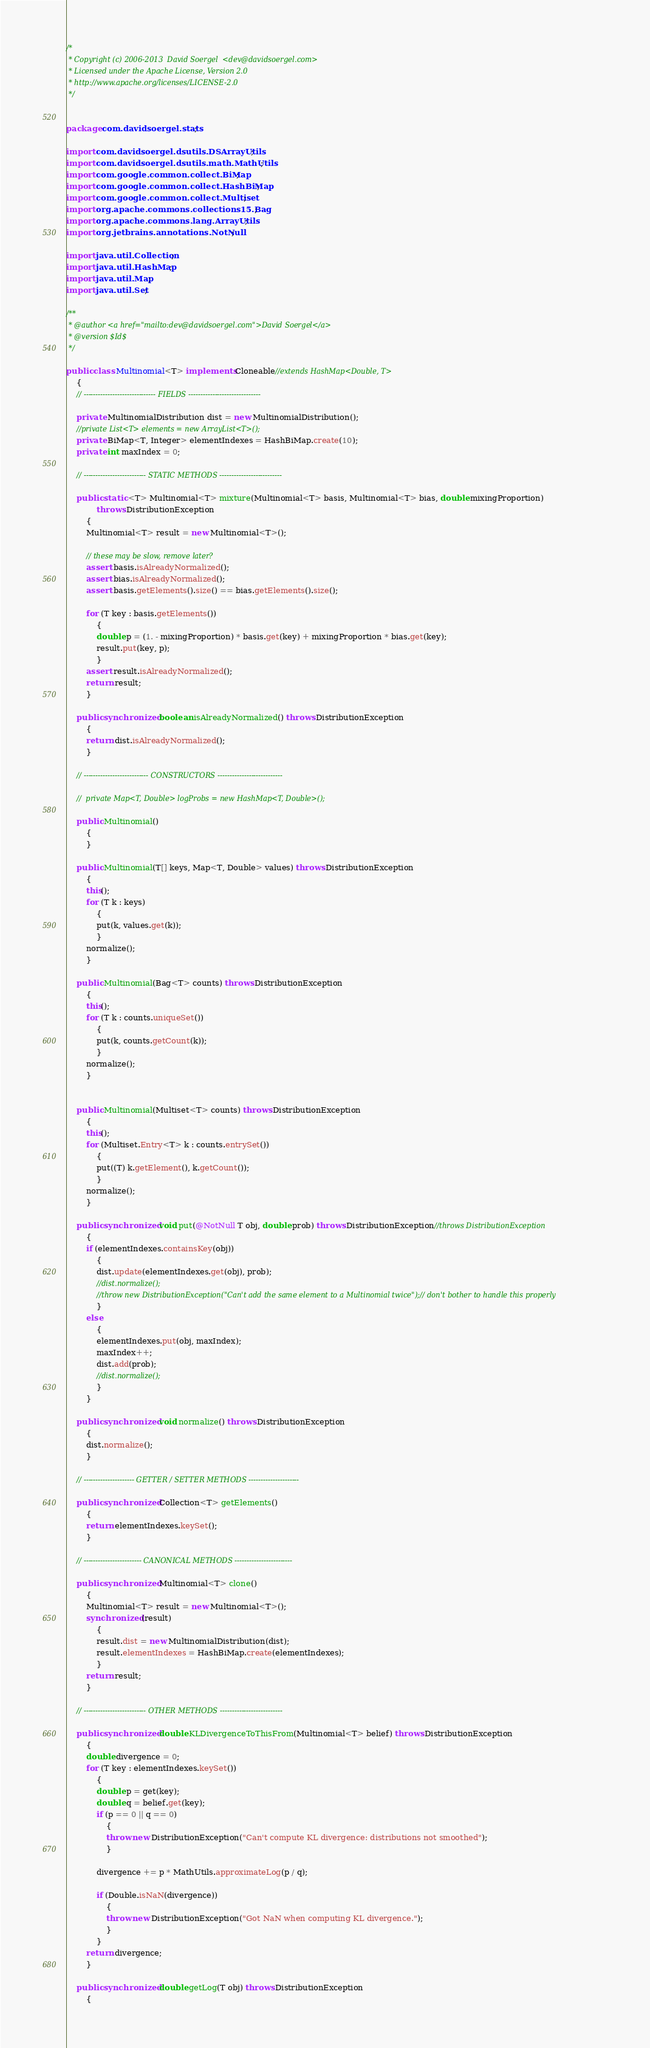<code> <loc_0><loc_0><loc_500><loc_500><_Java_>/*
 * Copyright (c) 2006-2013  David Soergel  <dev@davidsoergel.com>
 * Licensed under the Apache License, Version 2.0
 * http://www.apache.org/licenses/LICENSE-2.0
 */


package com.davidsoergel.stats;

import com.davidsoergel.dsutils.DSArrayUtils;
import com.davidsoergel.dsutils.math.MathUtils;
import com.google.common.collect.BiMap;
import com.google.common.collect.HashBiMap;
import com.google.common.collect.Multiset;
import org.apache.commons.collections15.Bag;
import org.apache.commons.lang.ArrayUtils;
import org.jetbrains.annotations.NotNull;

import java.util.Collection;
import java.util.HashMap;
import java.util.Map;
import java.util.Set;

/**
 * @author <a href="mailto:dev@davidsoergel.com">David Soergel</a>
 * @version $Id$
 */

public class Multinomial<T> implements Cloneable//extends HashMap<Double, T>
	{
	// ------------------------------ FIELDS ------------------------------

	private MultinomialDistribution dist = new MultinomialDistribution();
	//private List<T> elements = new ArrayList<T>();
	private BiMap<T, Integer> elementIndexes = HashBiMap.create(10);
	private int maxIndex = 0;

	// -------------------------- STATIC METHODS --------------------------

	public static <T> Multinomial<T> mixture(Multinomial<T> basis, Multinomial<T> bias, double mixingProportion)
			throws DistributionException
		{
		Multinomial<T> result = new Multinomial<T>();

		// these may be slow, remove later?
		assert basis.isAlreadyNormalized();
		assert bias.isAlreadyNormalized();
		assert basis.getElements().size() == bias.getElements().size();

		for (T key : basis.getElements())
			{
			double p = (1. - mixingProportion) * basis.get(key) + mixingProportion * bias.get(key);
			result.put(key, p);
			}
		assert result.isAlreadyNormalized();
		return result;
		}

	public synchronized boolean isAlreadyNormalized() throws DistributionException
		{
		return dist.isAlreadyNormalized();
		}

	// --------------------------- CONSTRUCTORS ---------------------------

	//	private Map<T, Double> logProbs = new HashMap<T, Double>();

	public Multinomial()
		{
		}

	public Multinomial(T[] keys, Map<T, Double> values) throws DistributionException
		{
		this();
		for (T k : keys)
			{
			put(k, values.get(k));
			}
		normalize();
		}

	public Multinomial(Bag<T> counts) throws DistributionException
		{
		this();
		for (T k : counts.uniqueSet())
			{
			put(k, counts.getCount(k));
			}
		normalize();
		}


	public Multinomial(Multiset<T> counts) throws DistributionException
		{
		this();
		for (Multiset.Entry<T> k : counts.entrySet())
			{
			put((T) k.getElement(), k.getCount());
			}
		normalize();
		}

	public synchronized void put(@NotNull T obj, double prob) throws DistributionException//throws DistributionException
		{
		if (elementIndexes.containsKey(obj))
			{
			dist.update(elementIndexes.get(obj), prob);
			//dist.normalize();
			//throw new DistributionException("Can't add the same element to a Multinomial twice");// don't bother to handle this properly
			}
		else
			{
			elementIndexes.put(obj, maxIndex);
			maxIndex++;
			dist.add(prob);
			//dist.normalize();
			}
		}

	public synchronized void normalize() throws DistributionException
		{
		dist.normalize();
		}

	// --------------------- GETTER / SETTER METHODS ---------------------

	public synchronized Collection<T> getElements()
		{
		return elementIndexes.keySet();
		}

	// ------------------------ CANONICAL METHODS ------------------------

	public synchronized Multinomial<T> clone()
		{
		Multinomial<T> result = new Multinomial<T>();
		synchronized (result)
			{
			result.dist = new MultinomialDistribution(dist);
			result.elementIndexes = HashBiMap.create(elementIndexes);
			}
		return result;
		}

	// -------------------------- OTHER METHODS --------------------------

	public synchronized double KLDivergenceToThisFrom(Multinomial<T> belief) throws DistributionException
		{
		double divergence = 0;
		for (T key : elementIndexes.keySet())
			{
			double p = get(key);
			double q = belief.get(key);
			if (p == 0 || q == 0)
				{
				throw new DistributionException("Can't compute KL divergence: distributions not smoothed");
				}

			divergence += p * MathUtils.approximateLog(p / q);

			if (Double.isNaN(divergence))
				{
				throw new DistributionException("Got NaN when computing KL divergence.");
				}
			}
		return divergence;
		}

	public synchronized double getLog(T obj) throws DistributionException
		{</code> 